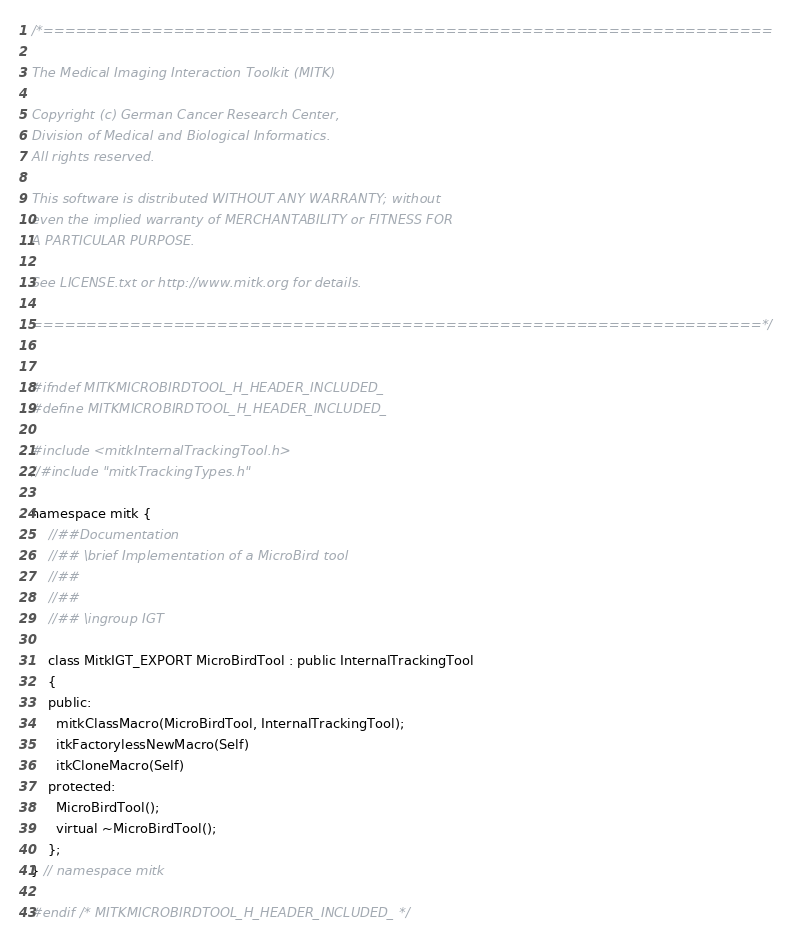Convert code to text. <code><loc_0><loc_0><loc_500><loc_500><_C_>/*===================================================================

The Medical Imaging Interaction Toolkit (MITK)

Copyright (c) German Cancer Research Center,
Division of Medical and Biological Informatics.
All rights reserved.

This software is distributed WITHOUT ANY WARRANTY; without
even the implied warranty of MERCHANTABILITY or FITNESS FOR
A PARTICULAR PURPOSE.

See LICENSE.txt or http://www.mitk.org for details.

===================================================================*/


#ifndef MITKMICROBIRDTOOL_H_HEADER_INCLUDED_
#define MITKMICROBIRDTOOL_H_HEADER_INCLUDED_

#include <mitkInternalTrackingTool.h>
//#include "mitkTrackingTypes.h"

namespace mitk {
    //##Documentation
    //## \brief Implementation of a MicroBird tool
    //##
    //##
    //## \ingroup IGT

    class MitkIGT_EXPORT MicroBirdTool : public InternalTrackingTool
    {
    public:
      mitkClassMacro(MicroBirdTool, InternalTrackingTool);
      itkFactorylessNewMacro(Self)
      itkCloneMacro(Self)
    protected:
      MicroBirdTool();
      virtual ~MicroBirdTool();
    };
} // namespace mitk

#endif /* MITKMICROBIRDTOOL_H_HEADER_INCLUDED_ */
</code> 